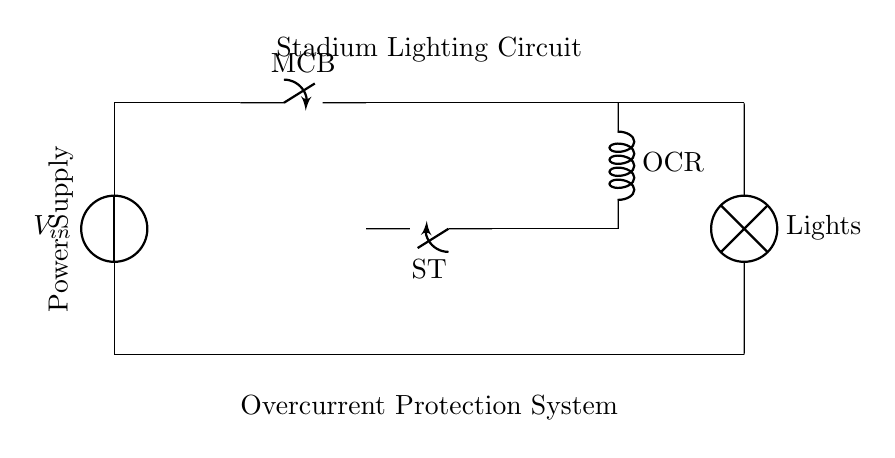What is the main protective device in this circuit? The main protective device is labeled as MCB, which stands for Miniature Circuit Breaker, and is indicated in the circuit diagram.
Answer: MCB What component connects the transformer to the overcurrent relay? The component connecting the transformer to the overcurrent relay is a simple line representing the electrical connection; no additional device is specified.
Answer: Line What is the purpose of the overcurrent relay (OCR) in this system? The overcurrent relay monitors the current flowing through the circuit and trips (disconnects the circuit) if the current exceeds a predetermined limit, thereby protecting the lighting system from overcurrent.
Answer: Trip protection How is the shunt trip (ST) activated? The shunt trip is activated by the overcurrent relay, which sends a signal when an overcurrent condition is detected, causing the shunt trip to open and disconnect the circuit.
Answer: By OCR What voltage source is indicated in this circuit? The voltage source in this circuit is labeled as Vin, indicating it is the initial power supply for the stadium lighting system.
Answer: Vin What is the load represented in this circuit? The load in this circuit is represented by the component labeled as "Lights," which indicates the stadium lighting system that is powered by the circuit.
Answer: Lights What does the current transformer do in this circuit? The current transformer measures the current flowing through the circuit and provides a signal for the overcurrent relay to monitor, ensuring protection against overloads or faults.
Answer: Measure current 